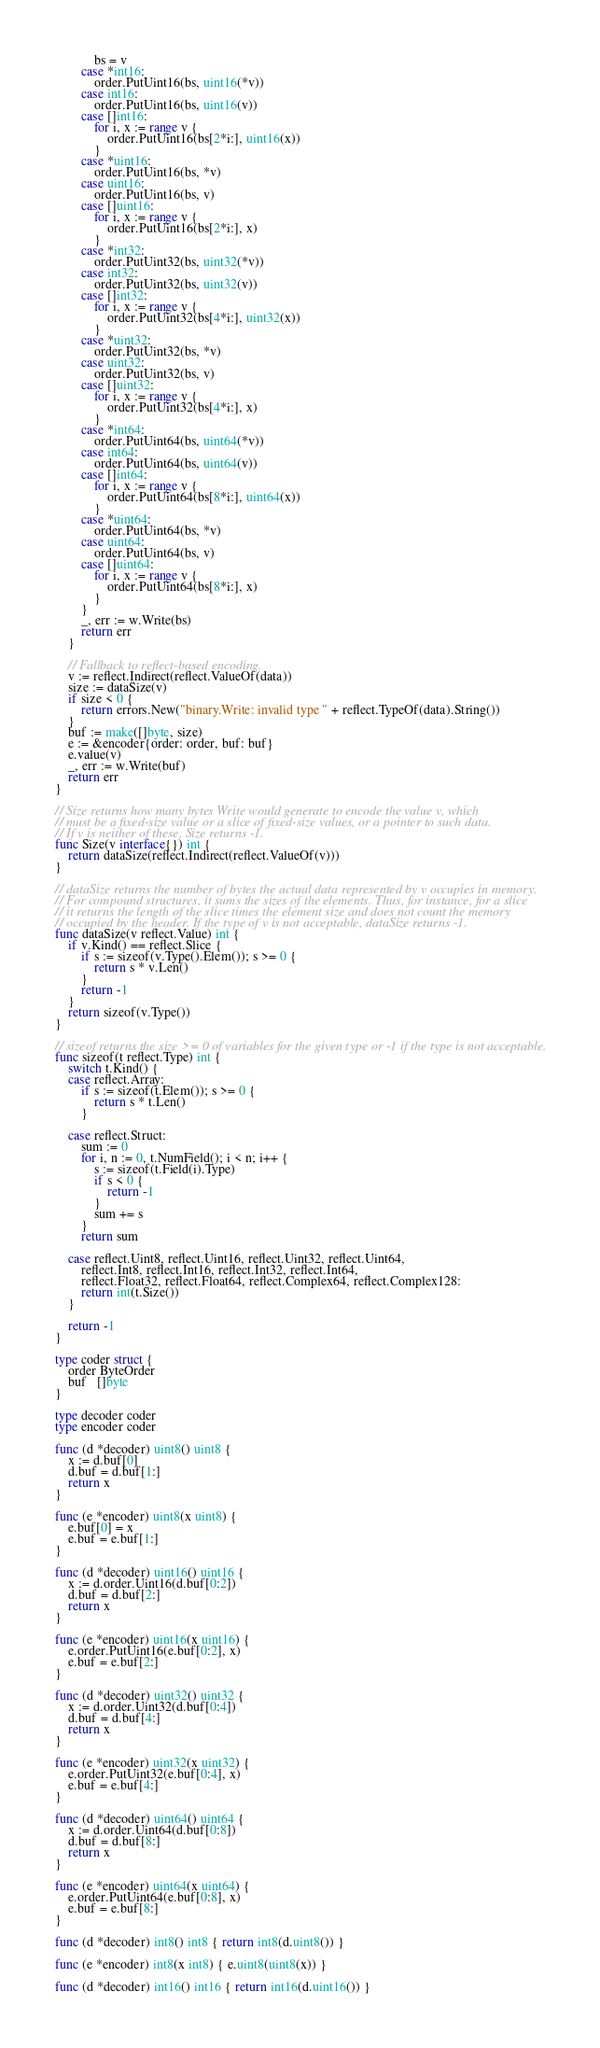<code> <loc_0><loc_0><loc_500><loc_500><_Go_>			bs = v
		case *int16:
			order.PutUint16(bs, uint16(*v))
		case int16:
			order.PutUint16(bs, uint16(v))
		case []int16:
			for i, x := range v {
				order.PutUint16(bs[2*i:], uint16(x))
			}
		case *uint16:
			order.PutUint16(bs, *v)
		case uint16:
			order.PutUint16(bs, v)
		case []uint16:
			for i, x := range v {
				order.PutUint16(bs[2*i:], x)
			}
		case *int32:
			order.PutUint32(bs, uint32(*v))
		case int32:
			order.PutUint32(bs, uint32(v))
		case []int32:
			for i, x := range v {
				order.PutUint32(bs[4*i:], uint32(x))
			}
		case *uint32:
			order.PutUint32(bs, *v)
		case uint32:
			order.PutUint32(bs, v)
		case []uint32:
			for i, x := range v {
				order.PutUint32(bs[4*i:], x)
			}
		case *int64:
			order.PutUint64(bs, uint64(*v))
		case int64:
			order.PutUint64(bs, uint64(v))
		case []int64:
			for i, x := range v {
				order.PutUint64(bs[8*i:], uint64(x))
			}
		case *uint64:
			order.PutUint64(bs, *v)
		case uint64:
			order.PutUint64(bs, v)
		case []uint64:
			for i, x := range v {
				order.PutUint64(bs[8*i:], x)
			}
		}
		_, err := w.Write(bs)
		return err
	}

	// Fallback to reflect-based encoding.
	v := reflect.Indirect(reflect.ValueOf(data))
	size := dataSize(v)
	if size < 0 {
		return errors.New("binary.Write: invalid type " + reflect.TypeOf(data).String())
	}
	buf := make([]byte, size)
	e := &encoder{order: order, buf: buf}
	e.value(v)
	_, err := w.Write(buf)
	return err
}

// Size returns how many bytes Write would generate to encode the value v, which
// must be a fixed-size value or a slice of fixed-size values, or a pointer to such data.
// If v is neither of these, Size returns -1.
func Size(v interface{}) int {
	return dataSize(reflect.Indirect(reflect.ValueOf(v)))
}

// dataSize returns the number of bytes the actual data represented by v occupies in memory.
// For compound structures, it sums the sizes of the elements. Thus, for instance, for a slice
// it returns the length of the slice times the element size and does not count the memory
// occupied by the header. If the type of v is not acceptable, dataSize returns -1.
func dataSize(v reflect.Value) int {
	if v.Kind() == reflect.Slice {
		if s := sizeof(v.Type().Elem()); s >= 0 {
			return s * v.Len()
		}
		return -1
	}
	return sizeof(v.Type())
}

// sizeof returns the size >= 0 of variables for the given type or -1 if the type is not acceptable.
func sizeof(t reflect.Type) int {
	switch t.Kind() {
	case reflect.Array:
		if s := sizeof(t.Elem()); s >= 0 {
			return s * t.Len()
		}

	case reflect.Struct:
		sum := 0
		for i, n := 0, t.NumField(); i < n; i++ {
			s := sizeof(t.Field(i).Type)
			if s < 0 {
				return -1
			}
			sum += s
		}
		return sum

	case reflect.Uint8, reflect.Uint16, reflect.Uint32, reflect.Uint64,
		reflect.Int8, reflect.Int16, reflect.Int32, reflect.Int64,
		reflect.Float32, reflect.Float64, reflect.Complex64, reflect.Complex128:
		return int(t.Size())
	}

	return -1
}

type coder struct {
	order ByteOrder
	buf   []byte
}

type decoder coder
type encoder coder

func (d *decoder) uint8() uint8 {
	x := d.buf[0]
	d.buf = d.buf[1:]
	return x
}

func (e *encoder) uint8(x uint8) {
	e.buf[0] = x
	e.buf = e.buf[1:]
}

func (d *decoder) uint16() uint16 {
	x := d.order.Uint16(d.buf[0:2])
	d.buf = d.buf[2:]
	return x
}

func (e *encoder) uint16(x uint16) {
	e.order.PutUint16(e.buf[0:2], x)
	e.buf = e.buf[2:]
}

func (d *decoder) uint32() uint32 {
	x := d.order.Uint32(d.buf[0:4])
	d.buf = d.buf[4:]
	return x
}

func (e *encoder) uint32(x uint32) {
	e.order.PutUint32(e.buf[0:4], x)
	e.buf = e.buf[4:]
}

func (d *decoder) uint64() uint64 {
	x := d.order.Uint64(d.buf[0:8])
	d.buf = d.buf[8:]
	return x
}

func (e *encoder) uint64(x uint64) {
	e.order.PutUint64(e.buf[0:8], x)
	e.buf = e.buf[8:]
}

func (d *decoder) int8() int8 { return int8(d.uint8()) }

func (e *encoder) int8(x int8) { e.uint8(uint8(x)) }

func (d *decoder) int16() int16 { return int16(d.uint16()) }
</code> 